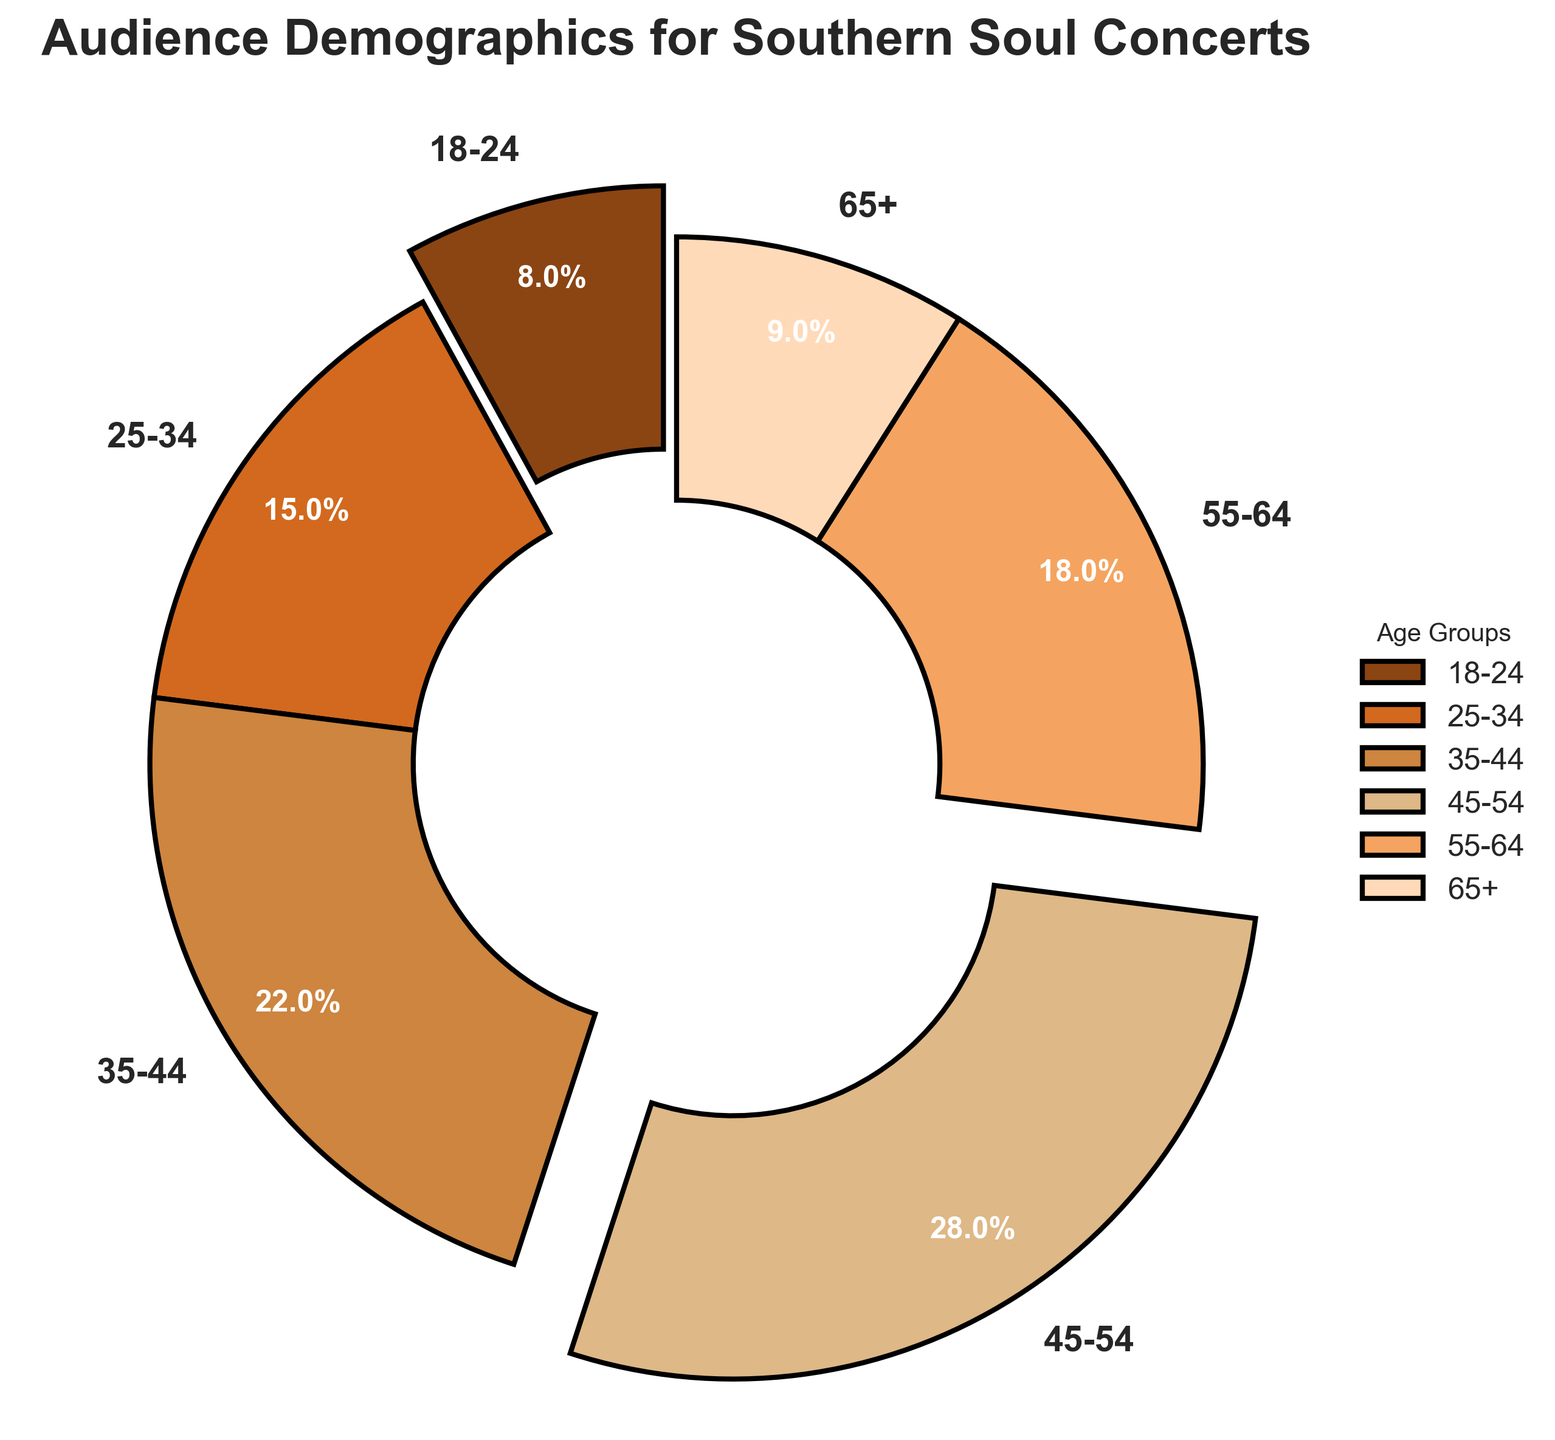What is the largest age group attending Southern soul concerts? The largest age group can be identified by finding the segment of the pie chart with the highest percentage. The 45-54 age group has the largest slice, which is 28%.
Answer: 45-54 Which age group has the smallest representation in the audience? The smallest segment is determined by looking for the slice with the lowest percentage. The 18-24 age group has the smallest slice at 8%.
Answer: 18-24 What is the total percentage of audience members over 45 years old? To find the total percentage of audience members over 45, add the percentages of the 45-54, 55-64, and 65+ age groups: 28% + 18% + 9% = 55%.
Answer: 55% Compare the size of the 25-34 and 55-64 age groups. Which is larger and by how much? The 25-34 age group is 15%, and the 55-64 age group is 18%. To find the difference, subtract the smaller percentage from the larger one: 18% - 15% = 3%. The 55-64 age group is larger by 3 percentage points.
Answer: 55-64 by 3% What is the combined percentage of the two youngest age groups? Add the percentages of the 18-24 and 25-34 age groups: 8% + 15% = 23%.
Answer: 23% Which segment of the pie chart is exploded? Why might this be effective? The segments exploded are the 18-24 and 45-54 age groups. This visual technique helps highlight these particular groups, possibly to draw attention to their lowest and highest attendance.
Answer: 18-24 and 45-54 In terms of visual representation, which is the second-largest age group, and what percentage does it represent? Observing the pie chart, the second-largest segment after 45-54 is the 35-44 age group, representing 22%.
Answer: 35-44, 22% What percentage of the audience is between the ages of 35 and 54? Sum the percentages of the 35-44 and 45-54 age groups: 22% + 28% = 50%.
Answer: 50% Compare the 65+ age group with the 18-24 age group in terms of their respective audience sizes. The 18-24 age group represents 8% of the audience, while the 65+ age group represents 9%. The 65+ age group is slightly larger by 1 percentage point.
Answer: 65+ by 1% What can you infer about the age demographics of Southern soul concert audiences based on the pie chart? The majority of the audience is middle-aged, with the largest group being 45-54 years old at 28%. The 35-44 and 55-64 age groups also have significant representation, indicating a preference for Southern soul in these age ranges. Combined, these middle-aged groups form the bulk of the audience.
Answer: Middle-aged majority 